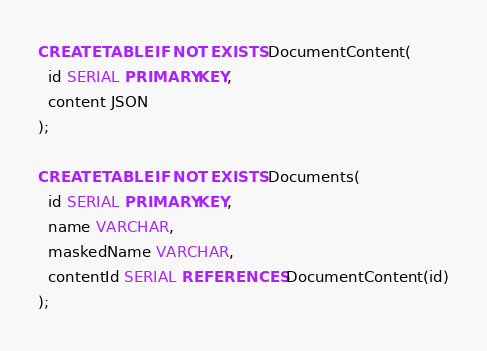Convert code to text. <code><loc_0><loc_0><loc_500><loc_500><_SQL_>CREATE TABLE IF NOT EXISTS DocumentContent(
  id SERIAL PRIMARY KEY,
  content JSON
);

CREATE TABLE IF NOT EXISTS Documents(
  id SERIAL PRIMARY KEY,
  name VARCHAR,
  maskedName VARCHAR,
  contentId SERIAL REFERENCES DocumentContent(id)
);</code> 